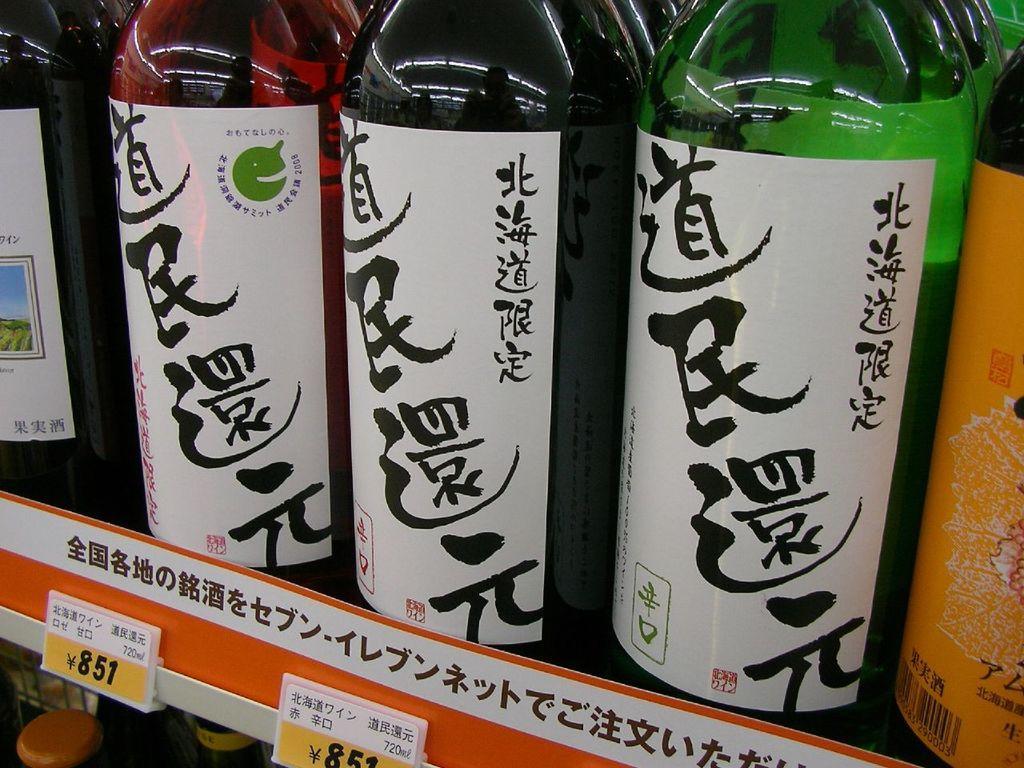How would you summarize this image in a sentence or two? These bottles are highlighted in this picture. On this bottles there are stickers. 